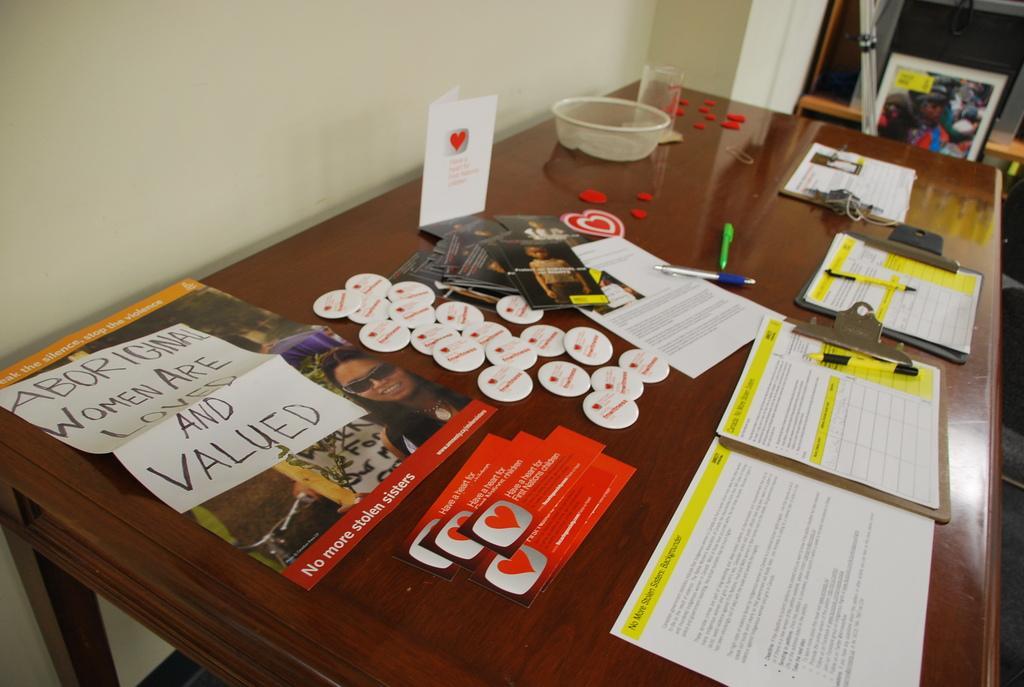How would you summarize this image in a sentence or two? In the picture I can see pads, pens, badges, some posters and a few more cards are placed on the wooden table. In the background of the image I can see the wall, some objects and glass doors. 